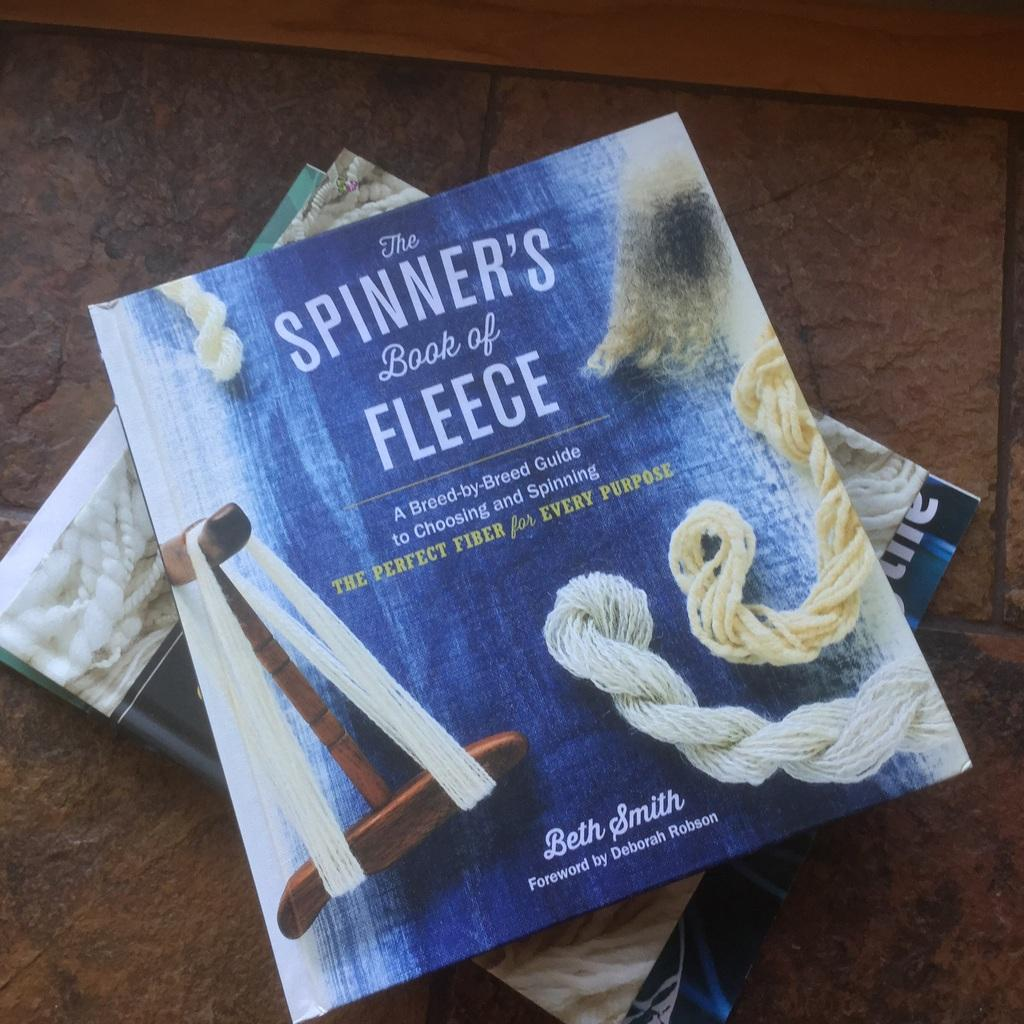<image>
Give a short and clear explanation of the subsequent image. books on the floor include The Spinner's Book of Fleece 